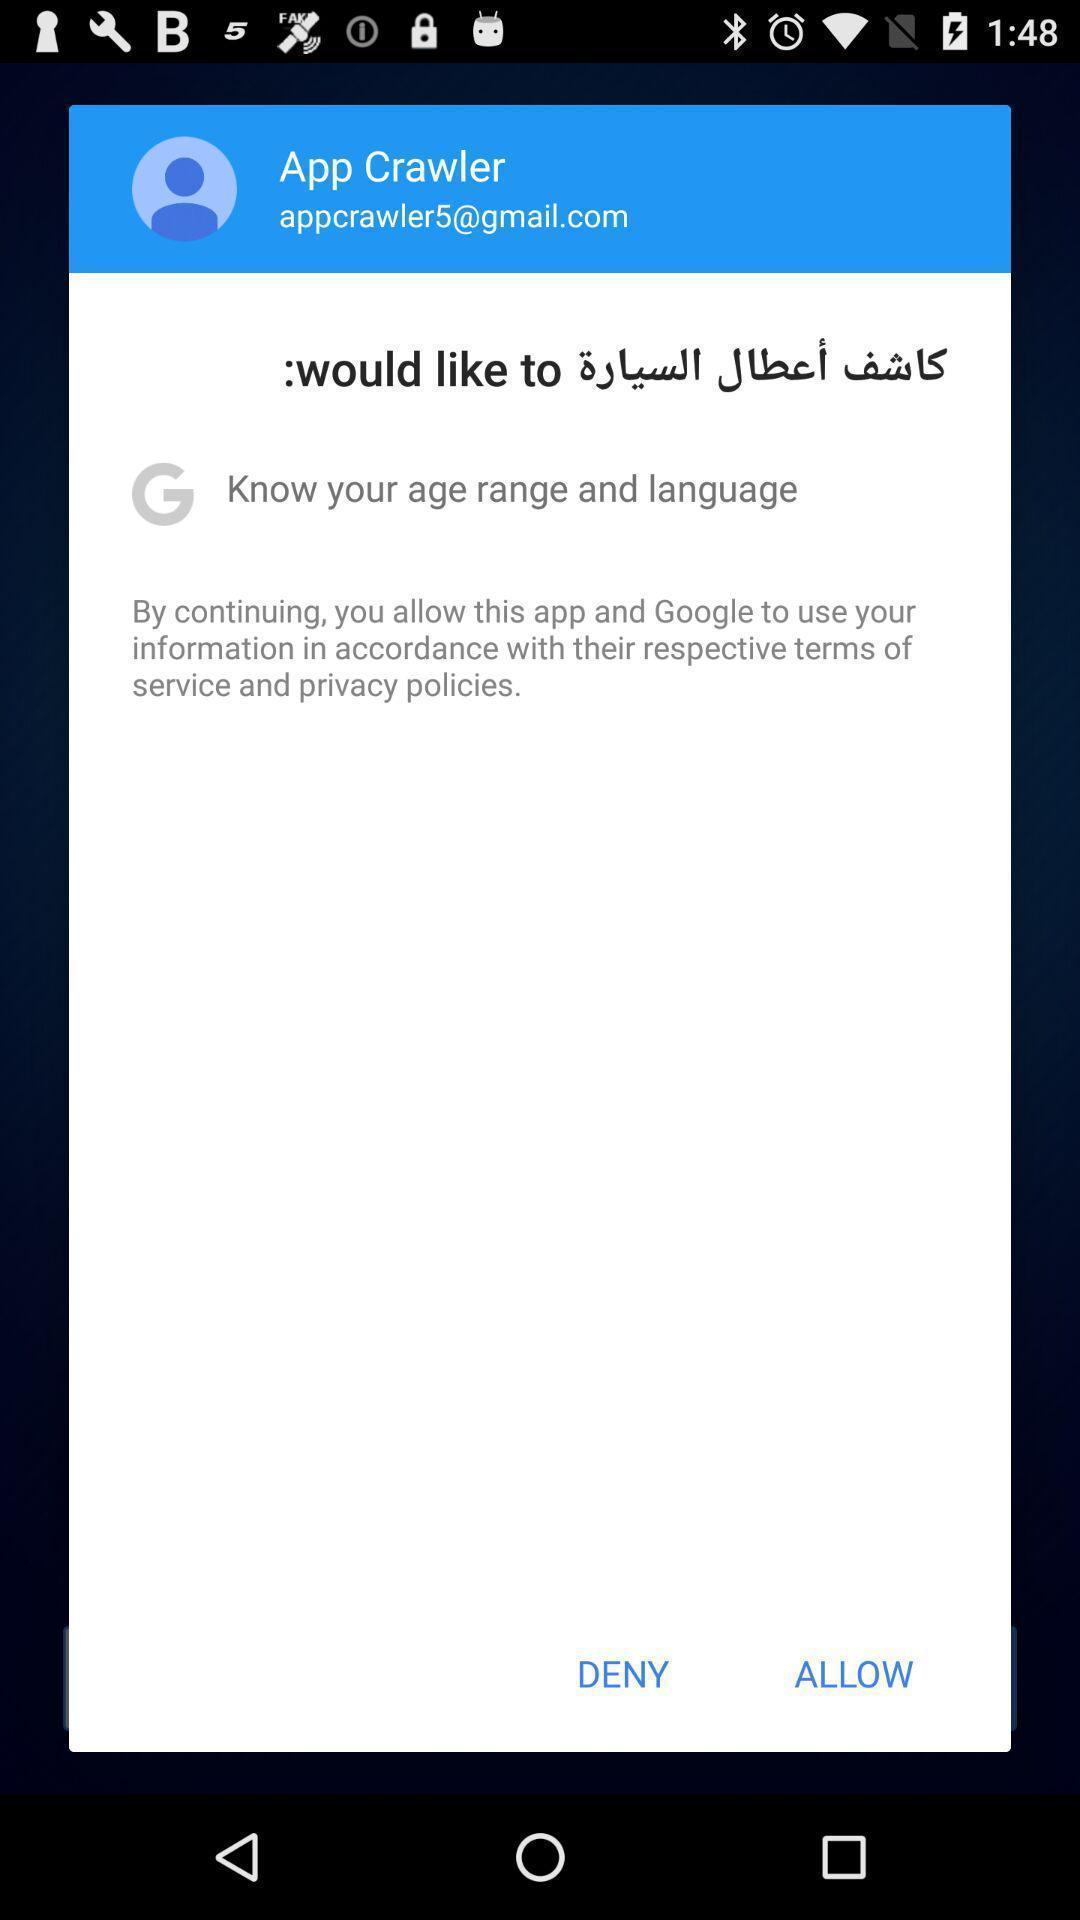Tell me what you see in this picture. Pop-up shows allow option to continue with social app. 